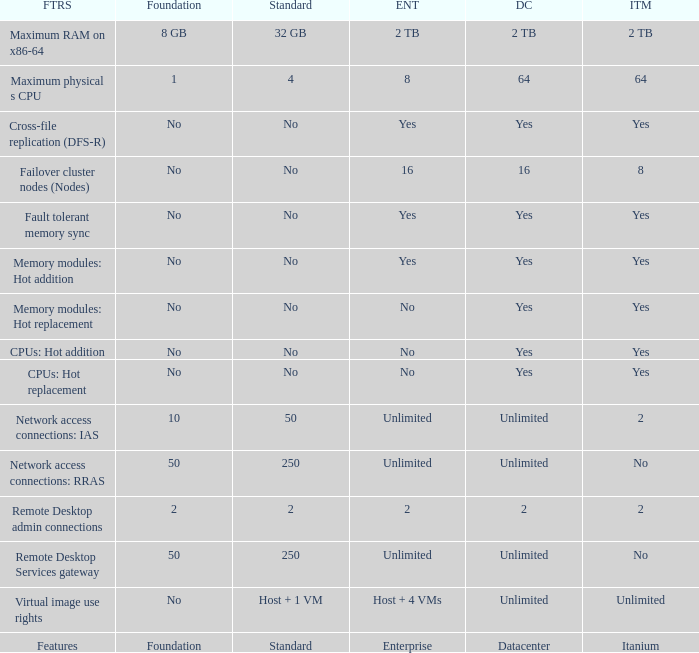Which Foundation has an Enterprise of 2? 2.0. 